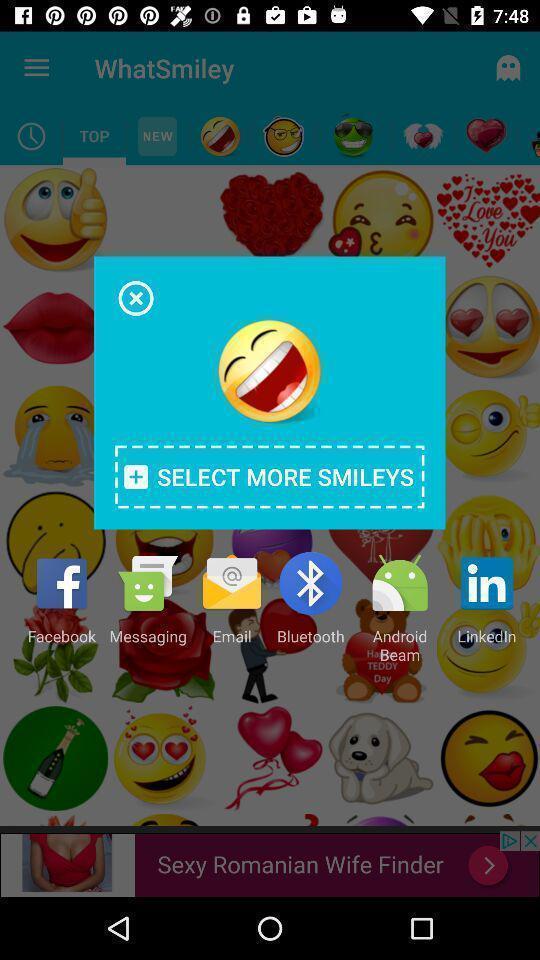What is the overall content of this screenshot? Popup of emoji to share across your applications. 